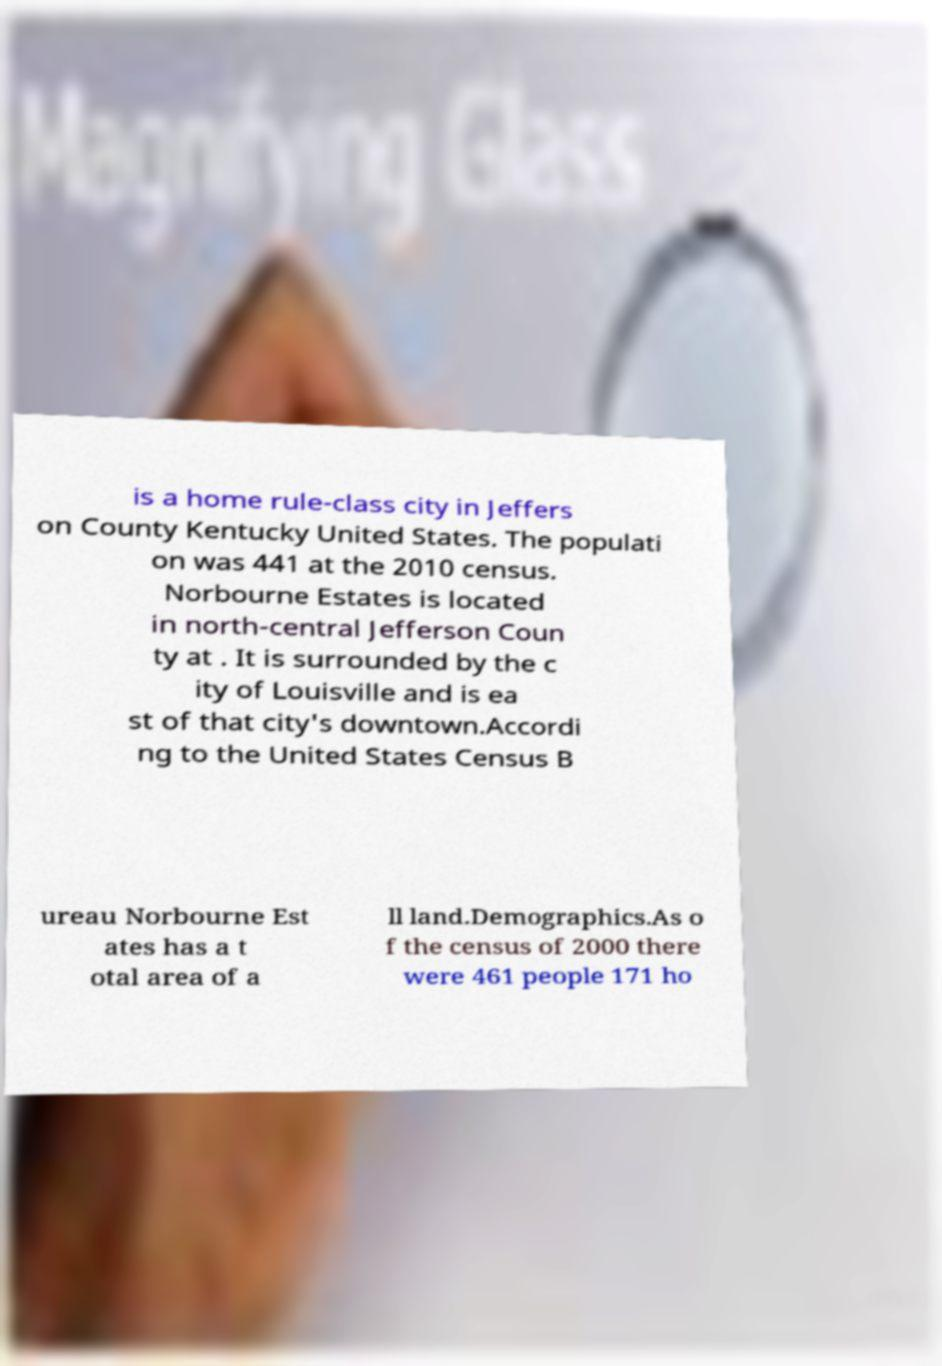There's text embedded in this image that I need extracted. Can you transcribe it verbatim? is a home rule-class city in Jeffers on County Kentucky United States. The populati on was 441 at the 2010 census. Norbourne Estates is located in north-central Jefferson Coun ty at . It is surrounded by the c ity of Louisville and is ea st of that city's downtown.Accordi ng to the United States Census B ureau Norbourne Est ates has a t otal area of a ll land.Demographics.As o f the census of 2000 there were 461 people 171 ho 